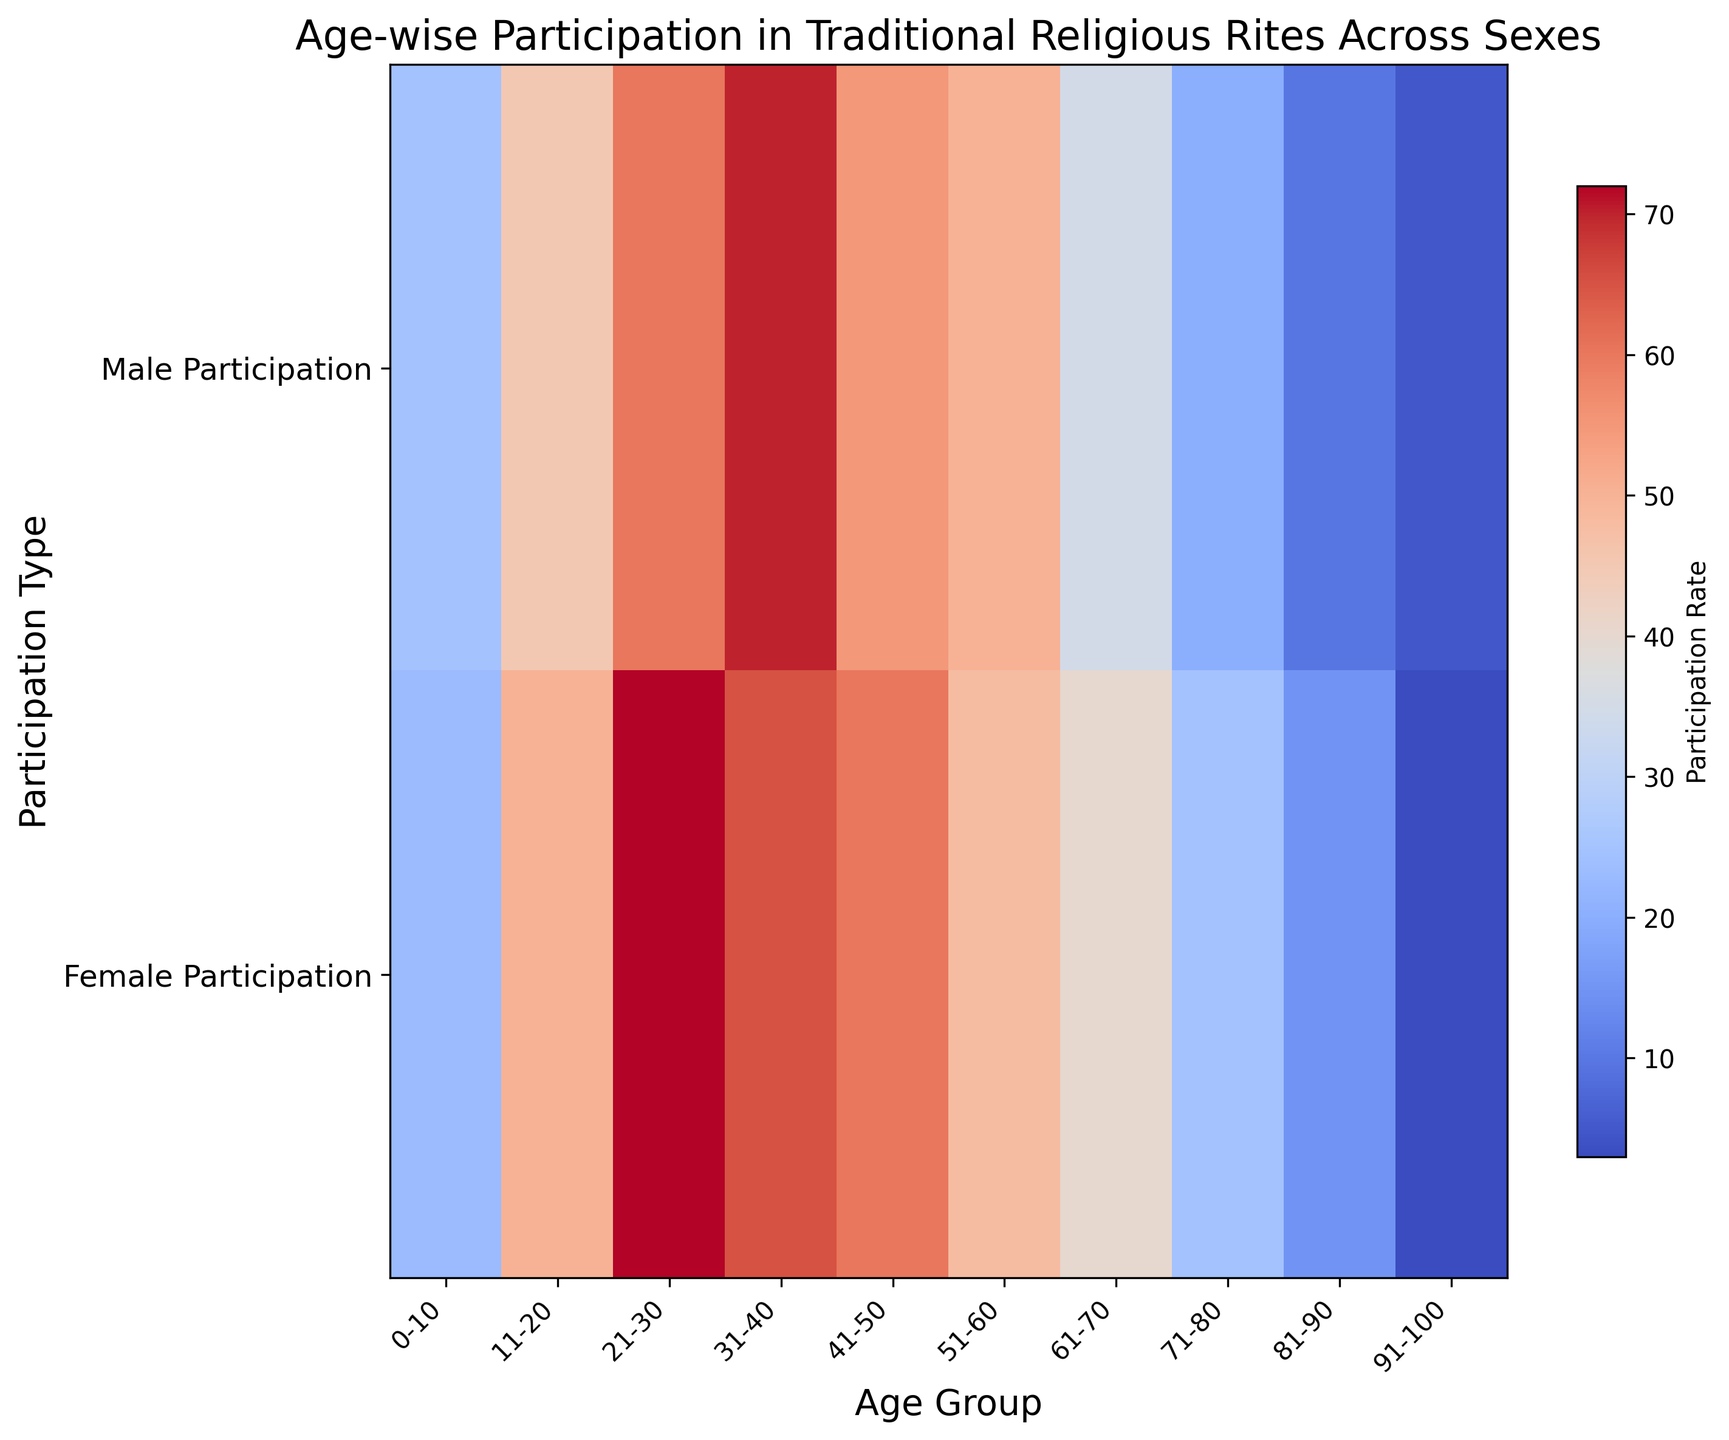What is the total participation rate for males aged 21-30 and 31-40 combined? Add the male participation rates for the 21-30 and 31-40 age groups: 60 + 70 = 130
Answer: 130 Which sex shows the highest participation rate in the 21-30 age group? Compare the participation rate for males (60) and females (72) in the 21-30 age group. The female participation rate (72) is higher.
Answer: Female At which age group does female participation start to decline compared to the previous age group? Analyze the pattern of female participation across age groups and identify the transition. The participation drops from 72 (21-30) to 65 (31-40).
Answer: 31-40 Which participation type shows more variation across age groups, male or female? Look at the overall variation in both rows (horizontal analysis). Males range from 5 to 70, while females range from 3 to 72. Males show slightly less range.
Answer: Female What is the difference in participation rates between males and females in the 41-50 age group? Subtract the male participation rate from the female participation rate for the 41-50 age group: 60 - 55 = 5
Answer: 5 In which age group is the male participation rate the closest to the female participation rate? Compare male and female rates for each age group and check the smallest difference. For the 51-60 age group, the difference is 2 (50 - 48).
Answer: 51-60 What color tone would you expect for the 61-70 age group for both sexes in the heatmap? Given the participation rates (35 for males and 40 for females) and the use of a 'coolwarm' colormap, expect a moderate color tone, transitioning between cooler and warmer colors but not extreme.
Answer: Moderate What is the overall trend in female participation as age increases from 0-100? Observing female participation rates from youngest to oldest (descending trend): 23, 50, 72, 65, 60, 48, 40, 25, 15, 3. Except initial increment, a general decline
Answer: General decline In which age group does male participation begin to significantly decline? Starting from the highest point (31-40 with 70), identify the age where a marked drop begins. Significant decline starts from 41-50 with 55
Answer: 41-50 